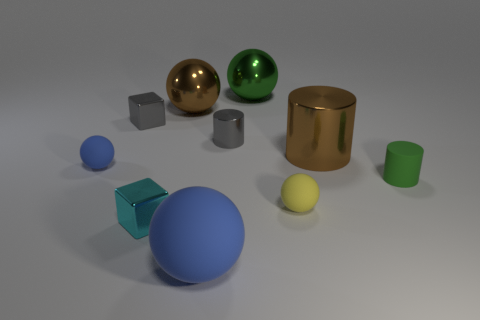What number of green cylinders have the same material as the tiny blue sphere? There are two green cylinders shown in the image and, based on their appearance, one of them has a reflective surface that matches the material of the tiny blue sphere. 